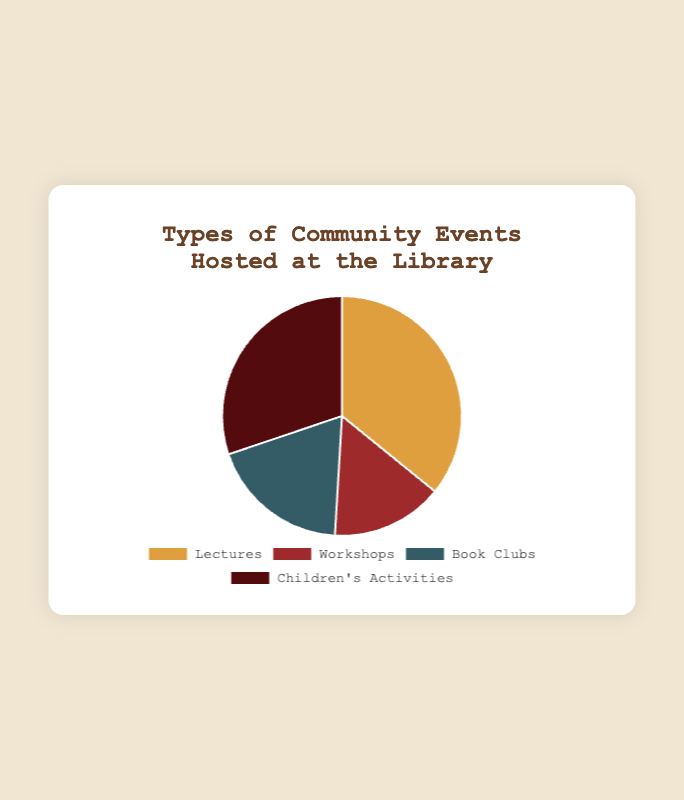How many types of community events are there? There are four distinct types of community events hosted at the library: Lectures, Workshops, Book Clubs, and Children's Activities. This can be counted directly from the unique labels in the pie chart.
Answer: 4 Which type of event has the highest attendance? By looking at the size of the slices in the pie chart, we can identify that the largest slice corresponds to Lectures, indicating it has the highest total attendance.
Answer: Lectures What percentage of attendees participated in Book Clubs? First, sum the attendances for all events: 40 + 55 + 25 + 15 + 30 + 20 + 35 + 45 = 265. The total attendance for Book Clubs is 30 + 20 = 50. To find the percentage, divide 50 by 265 and then multiply by 100: (50 / 265) * 100 ≈ 18.9%.
Answer: 18.9% Which two event types combined represent the smallest portion of the pie chart? The total attendance for Workshops is 25 + 15 = 40, and for Book Clubs, it's 30 + 20 = 50. Comparing these totals shows that the sum of Workshops and Book Clubs' attendance is 40 + 50 = 90, which is more than any single event type except Lectures (95), therefore, the two smallest event types together are Workshops and Children’s Activities (40 + 80 = 75).
Answer: Workshops and Children’s Activities If more children's events were added with a total increase of 25 attendees, what would be the new percentage for Children's Activities in the chart? The current total attendance is 265. With an additional 25 attendees for Children's Activities, the new total attendance for Children's Activities becomes 35 + 45 + 25 = 105. The new overall total attendance is 265 + 25 = 290. The new percentage: (105 / 290) * 100 ≈ 36.2%.
Answer: 36.2% What is the difference in attendance between the most attended and least attended event types? The attendance for Lectures is 40 + 55 = 95. For Workshops, it is 25 + 15 = 40, the smallest. The difference between these is 95 - 40 = 55.
Answer: 55 Compare the attendance of Children's Activities to that of Workshops. The attendance for Children's Activities is 35 + 45 = 80, and for Workshops, it is 25 + 15 = 40. Children's Activities have significantly greater attendance than Workshops (80 > 40).
Answer: Children's Activities have greater attendance than Workshops How many more attendees participated in Lectures than in Book Clubs? The total attendance for Lectures is 40 + 55 = 95, and for Book Clubs, it's 30 + 20 = 50. The difference is 95 - 50 = 45.
Answer: 45 If the library plans to maintain equal attendance distribution across all events, how many total attendees should each event type have? The current total attendance is 265. If attendance is to be distributed equally among the four event types, each should have 265 / 4 = 66.25, which may require rounding or other adjustments depending on practical constraints.
Answer: About 66 attendees per event type 